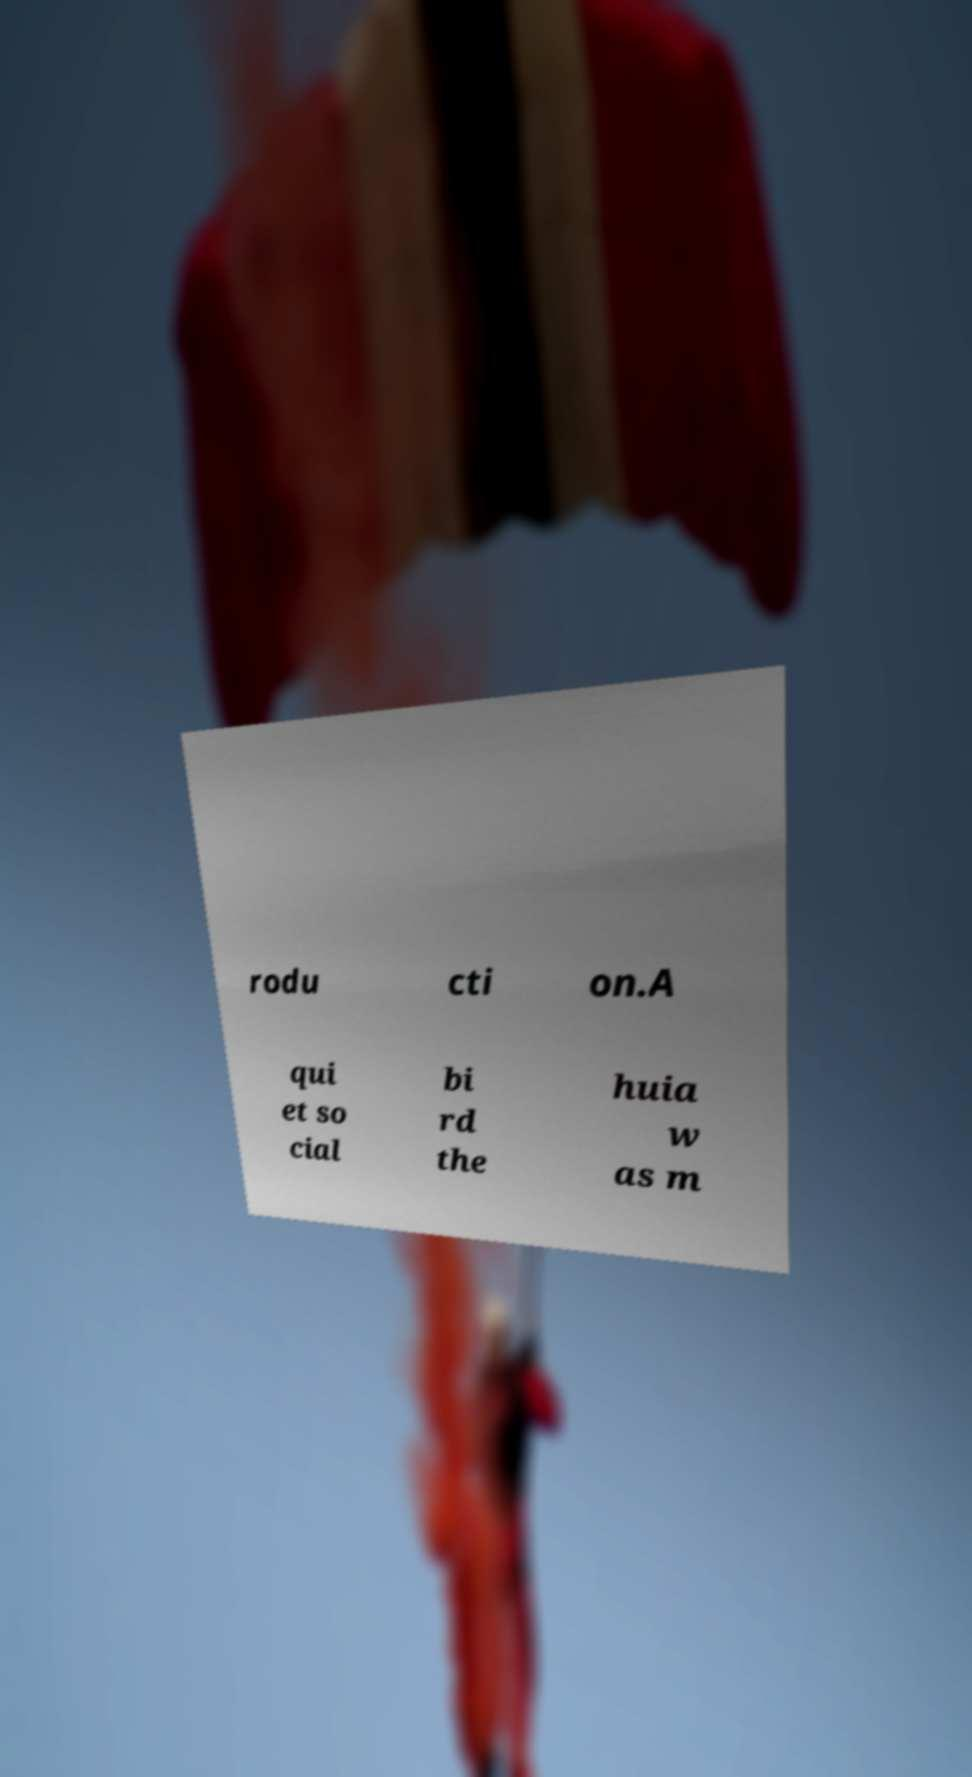Can you accurately transcribe the text from the provided image for me? rodu cti on.A qui et so cial bi rd the huia w as m 